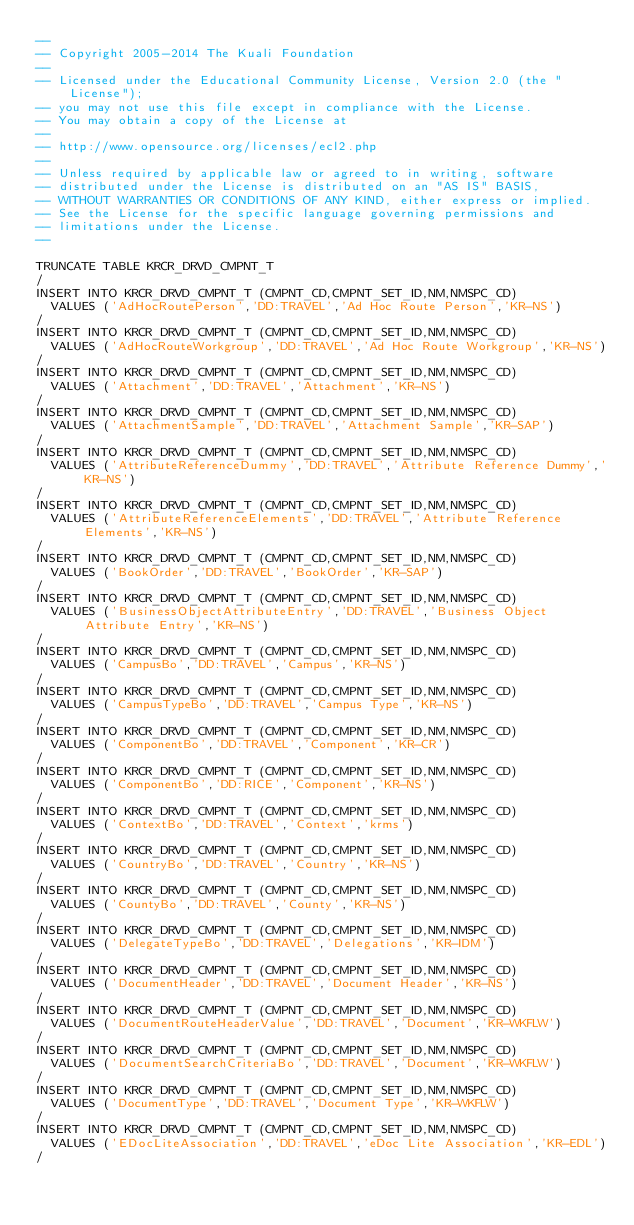<code> <loc_0><loc_0><loc_500><loc_500><_SQL_>--
-- Copyright 2005-2014 The Kuali Foundation
--
-- Licensed under the Educational Community License, Version 2.0 (the "License");
-- you may not use this file except in compliance with the License.
-- You may obtain a copy of the License at
--
-- http://www.opensource.org/licenses/ecl2.php
--
-- Unless required by applicable law or agreed to in writing, software
-- distributed under the License is distributed on an "AS IS" BASIS,
-- WITHOUT WARRANTIES OR CONDITIONS OF ANY KIND, either express or implied.
-- See the License for the specific language governing permissions and
-- limitations under the License.
--

TRUNCATE TABLE KRCR_DRVD_CMPNT_T
/
INSERT INTO KRCR_DRVD_CMPNT_T (CMPNT_CD,CMPNT_SET_ID,NM,NMSPC_CD)
  VALUES ('AdHocRoutePerson','DD:TRAVEL','Ad Hoc Route Person','KR-NS')
/
INSERT INTO KRCR_DRVD_CMPNT_T (CMPNT_CD,CMPNT_SET_ID,NM,NMSPC_CD)
  VALUES ('AdHocRouteWorkgroup','DD:TRAVEL','Ad Hoc Route Workgroup','KR-NS')
/
INSERT INTO KRCR_DRVD_CMPNT_T (CMPNT_CD,CMPNT_SET_ID,NM,NMSPC_CD)
  VALUES ('Attachment','DD:TRAVEL','Attachment','KR-NS')
/
INSERT INTO KRCR_DRVD_CMPNT_T (CMPNT_CD,CMPNT_SET_ID,NM,NMSPC_CD)
  VALUES ('AttachmentSample','DD:TRAVEL','Attachment Sample','KR-SAP')
/
INSERT INTO KRCR_DRVD_CMPNT_T (CMPNT_CD,CMPNT_SET_ID,NM,NMSPC_CD)
  VALUES ('AttributeReferenceDummy','DD:TRAVEL','Attribute Reference Dummy','KR-NS')
/
INSERT INTO KRCR_DRVD_CMPNT_T (CMPNT_CD,CMPNT_SET_ID,NM,NMSPC_CD)
  VALUES ('AttributeReferenceElements','DD:TRAVEL','Attribute Reference Elements','KR-NS')
/
INSERT INTO KRCR_DRVD_CMPNT_T (CMPNT_CD,CMPNT_SET_ID,NM,NMSPC_CD)
  VALUES ('BookOrder','DD:TRAVEL','BookOrder','KR-SAP')
/
INSERT INTO KRCR_DRVD_CMPNT_T (CMPNT_CD,CMPNT_SET_ID,NM,NMSPC_CD)
  VALUES ('BusinessObjectAttributeEntry','DD:TRAVEL','Business Object Attribute Entry','KR-NS')
/
INSERT INTO KRCR_DRVD_CMPNT_T (CMPNT_CD,CMPNT_SET_ID,NM,NMSPC_CD)
  VALUES ('CampusBo','DD:TRAVEL','Campus','KR-NS')
/
INSERT INTO KRCR_DRVD_CMPNT_T (CMPNT_CD,CMPNT_SET_ID,NM,NMSPC_CD)
  VALUES ('CampusTypeBo','DD:TRAVEL','Campus Type','KR-NS')
/
INSERT INTO KRCR_DRVD_CMPNT_T (CMPNT_CD,CMPNT_SET_ID,NM,NMSPC_CD)
  VALUES ('ComponentBo','DD:TRAVEL','Component','KR-CR')
/
INSERT INTO KRCR_DRVD_CMPNT_T (CMPNT_CD,CMPNT_SET_ID,NM,NMSPC_CD)
  VALUES ('ComponentBo','DD:RICE','Component','KR-NS')
/
INSERT INTO KRCR_DRVD_CMPNT_T (CMPNT_CD,CMPNT_SET_ID,NM,NMSPC_CD)
  VALUES ('ContextBo','DD:TRAVEL','Context','krms')
/
INSERT INTO KRCR_DRVD_CMPNT_T (CMPNT_CD,CMPNT_SET_ID,NM,NMSPC_CD)
  VALUES ('CountryBo','DD:TRAVEL','Country','KR-NS')
/
INSERT INTO KRCR_DRVD_CMPNT_T (CMPNT_CD,CMPNT_SET_ID,NM,NMSPC_CD)
  VALUES ('CountyBo','DD:TRAVEL','County','KR-NS')
/
INSERT INTO KRCR_DRVD_CMPNT_T (CMPNT_CD,CMPNT_SET_ID,NM,NMSPC_CD)
  VALUES ('DelegateTypeBo','DD:TRAVEL','Delegations','KR-IDM')
/
INSERT INTO KRCR_DRVD_CMPNT_T (CMPNT_CD,CMPNT_SET_ID,NM,NMSPC_CD)
  VALUES ('DocumentHeader','DD:TRAVEL','Document Header','KR-NS')
/
INSERT INTO KRCR_DRVD_CMPNT_T (CMPNT_CD,CMPNT_SET_ID,NM,NMSPC_CD)
  VALUES ('DocumentRouteHeaderValue','DD:TRAVEL','Document','KR-WKFLW')
/
INSERT INTO KRCR_DRVD_CMPNT_T (CMPNT_CD,CMPNT_SET_ID,NM,NMSPC_CD)
  VALUES ('DocumentSearchCriteriaBo','DD:TRAVEL','Document','KR-WKFLW')
/
INSERT INTO KRCR_DRVD_CMPNT_T (CMPNT_CD,CMPNT_SET_ID,NM,NMSPC_CD)
  VALUES ('DocumentType','DD:TRAVEL','Document Type','KR-WKFLW')
/
INSERT INTO KRCR_DRVD_CMPNT_T (CMPNT_CD,CMPNT_SET_ID,NM,NMSPC_CD)
  VALUES ('EDocLiteAssociation','DD:TRAVEL','eDoc Lite Association','KR-EDL')
/</code> 